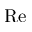Convert formula to latex. <formula><loc_0><loc_0><loc_500><loc_500>R e</formula> 